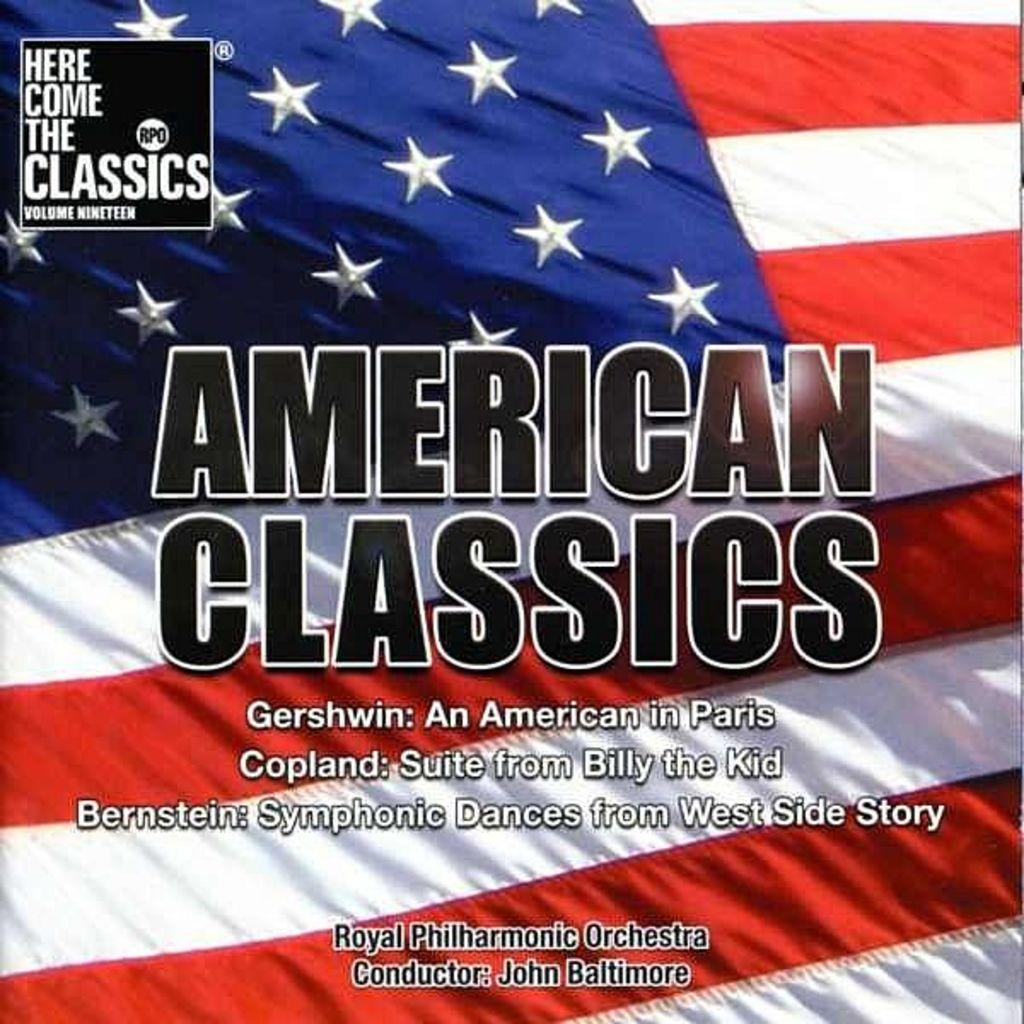What is present in the image that represents a visual display? There is a poster in the image. What is depicted on the poster? The poster contains an image of a flag. Are there any words or letters on the poster? Yes, there is text on the poster. How many rabbits can be seen reading a book in the image? There are no rabbits or books present in the image; it features a poster with an image of a flag and text. 